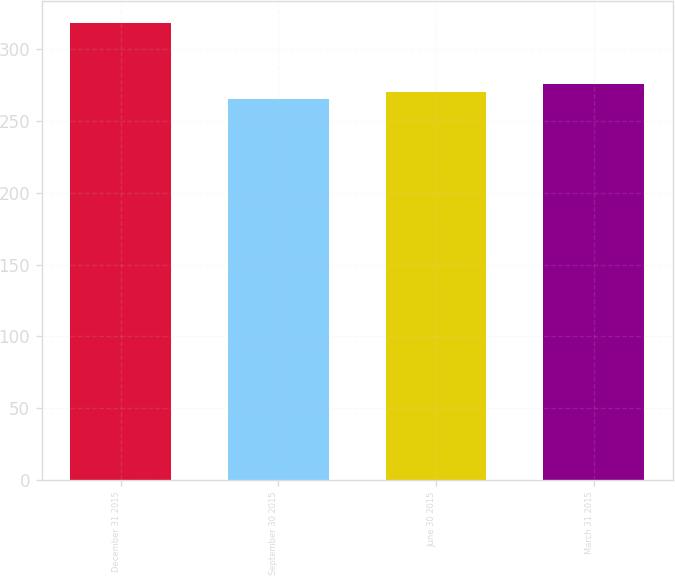<chart> <loc_0><loc_0><loc_500><loc_500><bar_chart><fcel>December 31 2015<fcel>September 30 2015<fcel>June 30 2015<fcel>March 31 2015<nl><fcel>318<fcel>265<fcel>270.3<fcel>275.6<nl></chart> 